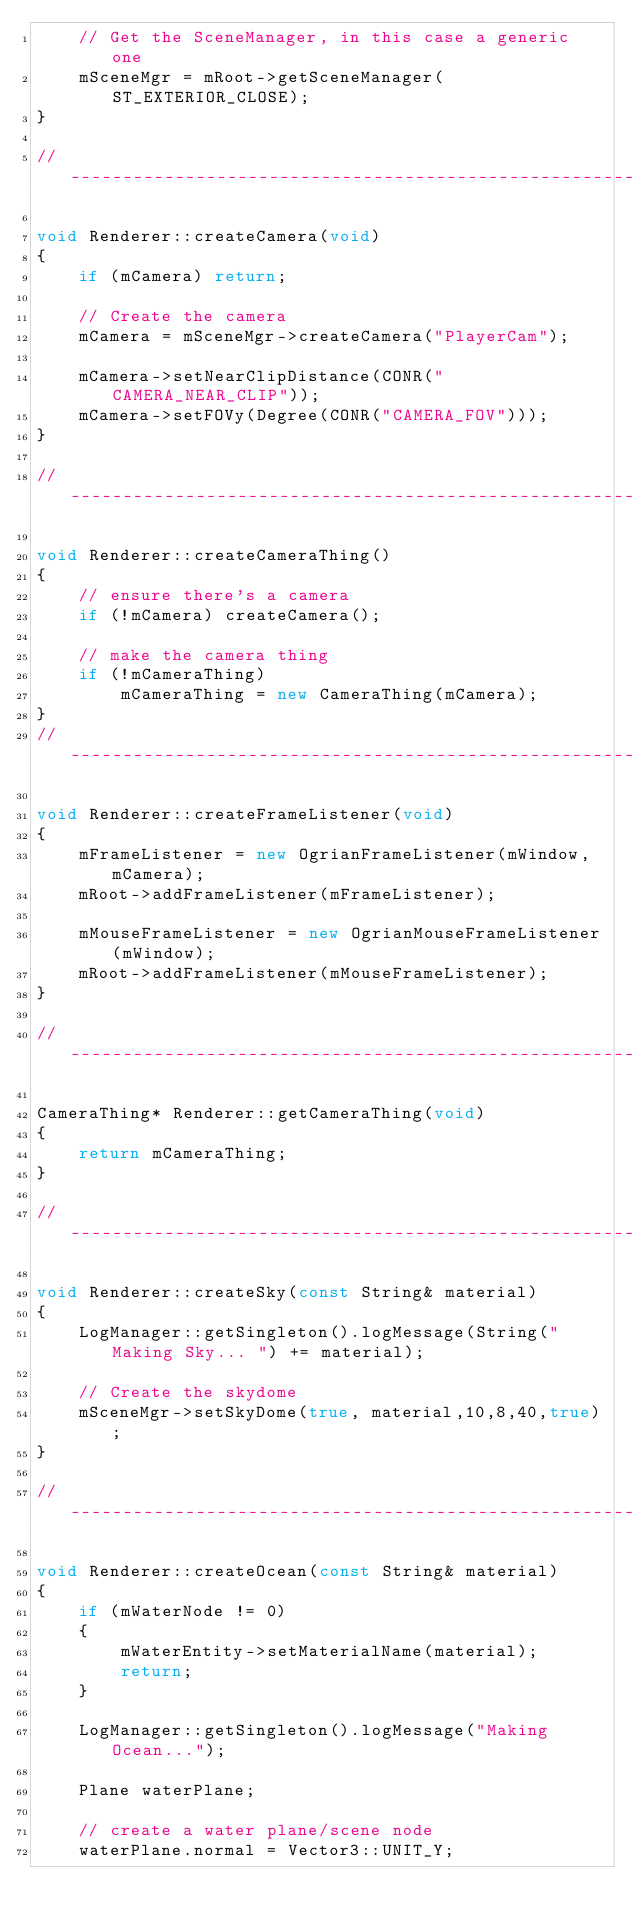Convert code to text. <code><loc_0><loc_0><loc_500><loc_500><_C++_>    // Get the SceneManager, in this case a generic one
    mSceneMgr = mRoot->getSceneManager(ST_EXTERIOR_CLOSE);
}

//----------------------------------------------------------------------------

void Renderer::createCamera(void)
{
	if (mCamera) return;

    // Create the camera
    mCamera = mSceneMgr->createCamera("PlayerCam");

    mCamera->setNearClipDistance(CONR("CAMERA_NEAR_CLIP"));
	mCamera->setFOVy(Degree(CONR("CAMERA_FOV")));
}

//----------------------------------------------------------------------------

void Renderer::createCameraThing()
{
	// ensure there's a camera
	if (!mCamera) createCamera();

	// make the camera thing
	if (!mCameraThing)
		mCameraThing = new CameraThing(mCamera);
}
//----------------------------------------------------------------------------

void Renderer::createFrameListener(void)
{
    mFrameListener = new OgrianFrameListener(mWindow, mCamera);
    mRoot->addFrameListener(mFrameListener);
	
    mMouseFrameListener = new OgrianMouseFrameListener(mWindow);
    mRoot->addFrameListener(mMouseFrameListener);
}

//----------------------------------------------------------------------------
	
CameraThing* Renderer::getCameraThing(void)
{
	return mCameraThing;
}

//----------------------------------------------------------------------------

void Renderer::createSky(const String& material)
{
	LogManager::getSingleton().logMessage(String("Making Sky... ") += material);

    // Create the skydome
	mSceneMgr->setSkyDome(true, material,10,8,40,true);
}

//----------------------------------------------------------------------------

void Renderer::createOcean(const String& material)
{
	if (mWaterNode != 0)
	{
		mWaterEntity->setMaterialName(material);
		return;
	}

	LogManager::getSingleton().logMessage("Making Ocean...");

    Plane waterPlane;
    
    // create a water plane/scene node
    waterPlane.normal = Vector3::UNIT_Y; </code> 